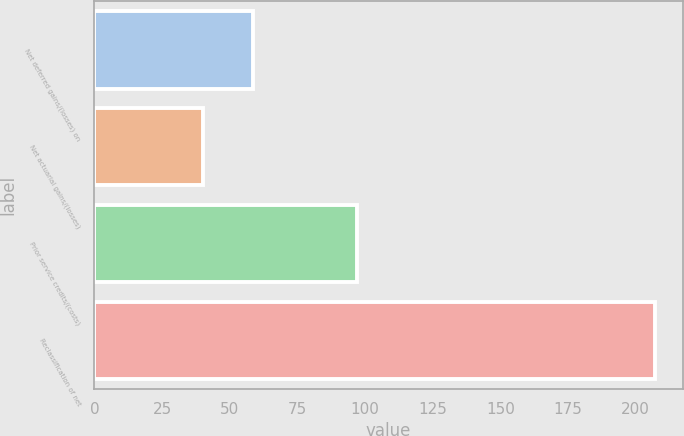Convert chart. <chart><loc_0><loc_0><loc_500><loc_500><bar_chart><fcel>Net deferred gains/(losses) on<fcel>Net actuarial gains/(losses)<fcel>Prior service credits/(costs)<fcel>Reclassification of net<nl><fcel>58.6<fcel>40<fcel>97<fcel>207<nl></chart> 